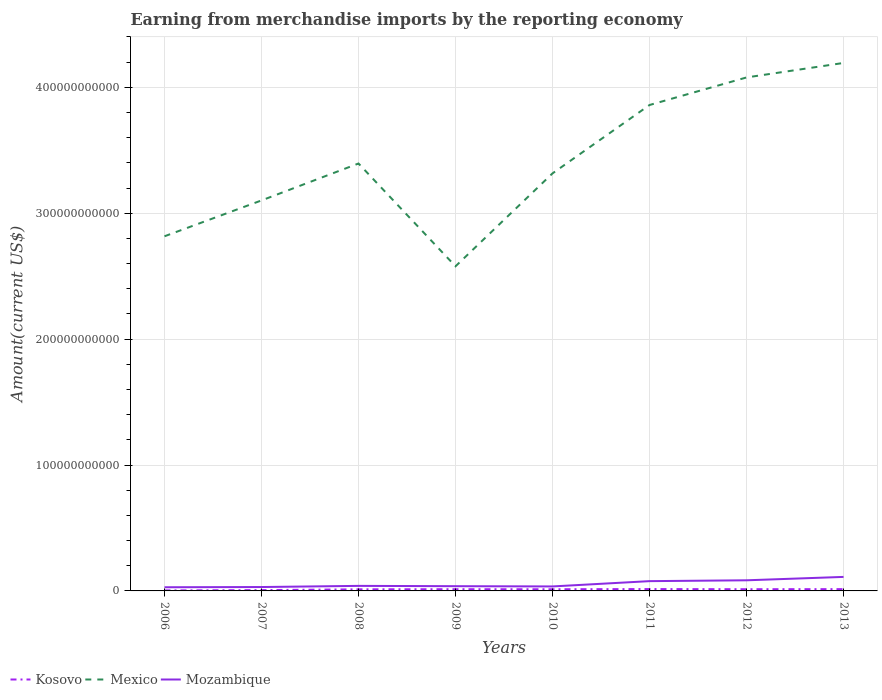How many different coloured lines are there?
Your answer should be very brief. 3. Does the line corresponding to Mozambique intersect with the line corresponding to Mexico?
Your response must be concise. No. Across all years, what is the maximum amount earned from merchandise imports in Mexico?
Ensure brevity in your answer.  2.58e+11. In which year was the amount earned from merchandise imports in Kosovo maximum?
Your answer should be compact. 2006. What is the total amount earned from merchandise imports in Kosovo in the graph?
Offer a terse response. -7.19e+08. What is the difference between the highest and the second highest amount earned from merchandise imports in Mozambique?
Your response must be concise. 8.22e+09. Is the amount earned from merchandise imports in Kosovo strictly greater than the amount earned from merchandise imports in Mozambique over the years?
Provide a succinct answer. Yes. What is the difference between two consecutive major ticks on the Y-axis?
Keep it short and to the point. 1.00e+11. Does the graph contain any zero values?
Offer a terse response. No. Where does the legend appear in the graph?
Offer a very short reply. Bottom left. How many legend labels are there?
Offer a terse response. 3. How are the legend labels stacked?
Keep it short and to the point. Horizontal. What is the title of the graph?
Provide a short and direct response. Earning from merchandise imports by the reporting economy. Does "Bermuda" appear as one of the legend labels in the graph?
Your answer should be very brief. No. What is the label or title of the Y-axis?
Your response must be concise. Amount(current US$). What is the Amount(current US$) of Kosovo in 2006?
Your answer should be very brief. 3.87e+08. What is the Amount(current US$) of Mexico in 2006?
Your response must be concise. 2.82e+11. What is the Amount(current US$) in Mozambique in 2006?
Your answer should be compact. 2.91e+09. What is the Amount(current US$) of Kosovo in 2007?
Your answer should be compact. 6.45e+08. What is the Amount(current US$) in Mexico in 2007?
Provide a short and direct response. 3.10e+11. What is the Amount(current US$) in Mozambique in 2007?
Your response must be concise. 3.09e+09. What is the Amount(current US$) in Kosovo in 2008?
Offer a terse response. 1.27e+09. What is the Amount(current US$) in Mexico in 2008?
Ensure brevity in your answer.  3.39e+11. What is the Amount(current US$) in Mozambique in 2008?
Provide a succinct answer. 4.01e+09. What is the Amount(current US$) in Kosovo in 2009?
Your answer should be compact. 1.36e+09. What is the Amount(current US$) in Mexico in 2009?
Keep it short and to the point. 2.58e+11. What is the Amount(current US$) of Mozambique in 2009?
Provide a short and direct response. 3.76e+09. What is the Amount(current US$) in Kosovo in 2010?
Keep it short and to the point. 1.32e+09. What is the Amount(current US$) in Mexico in 2010?
Keep it short and to the point. 3.32e+11. What is the Amount(current US$) in Mozambique in 2010?
Your answer should be compact. 3.56e+09. What is the Amount(current US$) in Kosovo in 2011?
Provide a succinct answer. 1.47e+09. What is the Amount(current US$) of Mexico in 2011?
Keep it short and to the point. 3.86e+11. What is the Amount(current US$) of Mozambique in 2011?
Give a very brief answer. 7.76e+09. What is the Amount(current US$) in Kosovo in 2012?
Make the answer very short. 1.35e+09. What is the Amount(current US$) in Mexico in 2012?
Offer a terse response. 4.08e+11. What is the Amount(current US$) in Mozambique in 2012?
Provide a short and direct response. 8.43e+09. What is the Amount(current US$) in Kosovo in 2013?
Keep it short and to the point. 1.42e+09. What is the Amount(current US$) in Mexico in 2013?
Your answer should be compact. 4.19e+11. What is the Amount(current US$) of Mozambique in 2013?
Keep it short and to the point. 1.11e+1. Across all years, what is the maximum Amount(current US$) in Kosovo?
Give a very brief answer. 1.47e+09. Across all years, what is the maximum Amount(current US$) of Mexico?
Make the answer very short. 4.19e+11. Across all years, what is the maximum Amount(current US$) in Mozambique?
Give a very brief answer. 1.11e+1. Across all years, what is the minimum Amount(current US$) of Kosovo?
Provide a short and direct response. 3.87e+08. Across all years, what is the minimum Amount(current US$) in Mexico?
Make the answer very short. 2.58e+11. Across all years, what is the minimum Amount(current US$) in Mozambique?
Make the answer very short. 2.91e+09. What is the total Amount(current US$) of Kosovo in the graph?
Keep it short and to the point. 9.23e+09. What is the total Amount(current US$) in Mexico in the graph?
Keep it short and to the point. 2.73e+12. What is the total Amount(current US$) of Mozambique in the graph?
Offer a terse response. 4.47e+1. What is the difference between the Amount(current US$) of Kosovo in 2006 and that in 2007?
Your answer should be compact. -2.58e+08. What is the difference between the Amount(current US$) of Mexico in 2006 and that in 2007?
Offer a terse response. -2.85e+1. What is the difference between the Amount(current US$) in Mozambique in 2006 and that in 2007?
Your response must be concise. -1.79e+08. What is the difference between the Amount(current US$) of Kosovo in 2006 and that in 2008?
Offer a terse response. -8.84e+08. What is the difference between the Amount(current US$) of Mexico in 2006 and that in 2008?
Your answer should be very brief. -5.78e+1. What is the difference between the Amount(current US$) in Mozambique in 2006 and that in 2008?
Ensure brevity in your answer.  -1.09e+09. What is the difference between the Amount(current US$) of Kosovo in 2006 and that in 2009?
Provide a succinct answer. -9.77e+08. What is the difference between the Amount(current US$) in Mexico in 2006 and that in 2009?
Provide a short and direct response. 2.38e+1. What is the difference between the Amount(current US$) of Mozambique in 2006 and that in 2009?
Make the answer very short. -8.50e+08. What is the difference between the Amount(current US$) in Kosovo in 2006 and that in 2010?
Provide a succinct answer. -9.32e+08. What is the difference between the Amount(current US$) of Mexico in 2006 and that in 2010?
Give a very brief answer. -5.00e+1. What is the difference between the Amount(current US$) of Mozambique in 2006 and that in 2010?
Give a very brief answer. -6.51e+08. What is the difference between the Amount(current US$) of Kosovo in 2006 and that in 2011?
Ensure brevity in your answer.  -1.09e+09. What is the difference between the Amount(current US$) of Mexico in 2006 and that in 2011?
Provide a succinct answer. -1.04e+11. What is the difference between the Amount(current US$) of Mozambique in 2006 and that in 2011?
Ensure brevity in your answer.  -4.85e+09. What is the difference between the Amount(current US$) of Kosovo in 2006 and that in 2012?
Provide a short and direct response. -9.65e+08. What is the difference between the Amount(current US$) of Mexico in 2006 and that in 2012?
Provide a short and direct response. -1.26e+11. What is the difference between the Amount(current US$) in Mozambique in 2006 and that in 2012?
Your answer should be very brief. -5.52e+09. What is the difference between the Amount(current US$) of Kosovo in 2006 and that in 2013?
Your answer should be compact. -1.03e+09. What is the difference between the Amount(current US$) in Mexico in 2006 and that in 2013?
Provide a short and direct response. -1.38e+11. What is the difference between the Amount(current US$) in Mozambique in 2006 and that in 2013?
Your answer should be very brief. -8.22e+09. What is the difference between the Amount(current US$) of Kosovo in 2007 and that in 2008?
Keep it short and to the point. -6.26e+08. What is the difference between the Amount(current US$) of Mexico in 2007 and that in 2008?
Ensure brevity in your answer.  -2.93e+1. What is the difference between the Amount(current US$) of Mozambique in 2007 and that in 2008?
Offer a very short reply. -9.16e+08. What is the difference between the Amount(current US$) in Kosovo in 2007 and that in 2009?
Offer a terse response. -7.19e+08. What is the difference between the Amount(current US$) of Mexico in 2007 and that in 2009?
Your answer should be compact. 5.23e+1. What is the difference between the Amount(current US$) of Mozambique in 2007 and that in 2009?
Offer a terse response. -6.72e+08. What is the difference between the Amount(current US$) in Kosovo in 2007 and that in 2010?
Provide a short and direct response. -6.74e+08. What is the difference between the Amount(current US$) of Mexico in 2007 and that in 2010?
Make the answer very short. -2.15e+1. What is the difference between the Amount(current US$) of Mozambique in 2007 and that in 2010?
Keep it short and to the point. -4.72e+08. What is the difference between the Amount(current US$) in Kosovo in 2007 and that in 2011?
Give a very brief answer. -8.27e+08. What is the difference between the Amount(current US$) in Mexico in 2007 and that in 2011?
Offer a terse response. -7.58e+1. What is the difference between the Amount(current US$) of Mozambique in 2007 and that in 2011?
Give a very brief answer. -4.67e+09. What is the difference between the Amount(current US$) of Kosovo in 2007 and that in 2012?
Keep it short and to the point. -7.07e+08. What is the difference between the Amount(current US$) of Mexico in 2007 and that in 2012?
Give a very brief answer. -9.77e+1. What is the difference between the Amount(current US$) in Mozambique in 2007 and that in 2012?
Your answer should be very brief. -5.34e+09. What is the difference between the Amount(current US$) in Kosovo in 2007 and that in 2013?
Provide a short and direct response. -7.72e+08. What is the difference between the Amount(current US$) in Mexico in 2007 and that in 2013?
Give a very brief answer. -1.09e+11. What is the difference between the Amount(current US$) in Mozambique in 2007 and that in 2013?
Provide a succinct answer. -8.04e+09. What is the difference between the Amount(current US$) of Kosovo in 2008 and that in 2009?
Ensure brevity in your answer.  -9.32e+07. What is the difference between the Amount(current US$) of Mexico in 2008 and that in 2009?
Your response must be concise. 8.16e+1. What is the difference between the Amount(current US$) in Mozambique in 2008 and that in 2009?
Provide a succinct answer. 2.44e+08. What is the difference between the Amount(current US$) in Kosovo in 2008 and that in 2010?
Provide a succinct answer. -4.82e+07. What is the difference between the Amount(current US$) of Mexico in 2008 and that in 2010?
Ensure brevity in your answer.  7.83e+09. What is the difference between the Amount(current US$) in Mozambique in 2008 and that in 2010?
Ensure brevity in your answer.  4.44e+08. What is the difference between the Amount(current US$) in Kosovo in 2008 and that in 2011?
Your response must be concise. -2.01e+08. What is the difference between the Amount(current US$) of Mexico in 2008 and that in 2011?
Provide a short and direct response. -4.65e+1. What is the difference between the Amount(current US$) of Mozambique in 2008 and that in 2011?
Your answer should be compact. -3.76e+09. What is the difference between the Amount(current US$) of Kosovo in 2008 and that in 2012?
Give a very brief answer. -8.09e+07. What is the difference between the Amount(current US$) of Mexico in 2008 and that in 2012?
Make the answer very short. -6.84e+1. What is the difference between the Amount(current US$) of Mozambique in 2008 and that in 2012?
Your response must be concise. -4.43e+09. What is the difference between the Amount(current US$) in Kosovo in 2008 and that in 2013?
Give a very brief answer. -1.46e+08. What is the difference between the Amount(current US$) of Mexico in 2008 and that in 2013?
Offer a very short reply. -7.99e+1. What is the difference between the Amount(current US$) in Mozambique in 2008 and that in 2013?
Provide a short and direct response. -7.12e+09. What is the difference between the Amount(current US$) of Kosovo in 2009 and that in 2010?
Provide a short and direct response. 4.51e+07. What is the difference between the Amount(current US$) in Mexico in 2009 and that in 2010?
Ensure brevity in your answer.  -7.38e+1. What is the difference between the Amount(current US$) of Mozambique in 2009 and that in 2010?
Make the answer very short. 2.00e+08. What is the difference between the Amount(current US$) of Kosovo in 2009 and that in 2011?
Your answer should be very brief. -1.08e+08. What is the difference between the Amount(current US$) in Mexico in 2009 and that in 2011?
Give a very brief answer. -1.28e+11. What is the difference between the Amount(current US$) in Mozambique in 2009 and that in 2011?
Your answer should be compact. -4.00e+09. What is the difference between the Amount(current US$) of Kosovo in 2009 and that in 2012?
Ensure brevity in your answer.  1.23e+07. What is the difference between the Amount(current US$) of Mexico in 2009 and that in 2012?
Your answer should be compact. -1.50e+11. What is the difference between the Amount(current US$) of Mozambique in 2009 and that in 2012?
Keep it short and to the point. -4.67e+09. What is the difference between the Amount(current US$) in Kosovo in 2009 and that in 2013?
Provide a short and direct response. -5.29e+07. What is the difference between the Amount(current US$) in Mexico in 2009 and that in 2013?
Offer a terse response. -1.62e+11. What is the difference between the Amount(current US$) of Mozambique in 2009 and that in 2013?
Make the answer very short. -7.37e+09. What is the difference between the Amount(current US$) of Kosovo in 2010 and that in 2011?
Give a very brief answer. -1.53e+08. What is the difference between the Amount(current US$) of Mexico in 2010 and that in 2011?
Give a very brief answer. -5.43e+1. What is the difference between the Amount(current US$) in Mozambique in 2010 and that in 2011?
Provide a short and direct response. -4.20e+09. What is the difference between the Amount(current US$) of Kosovo in 2010 and that in 2012?
Offer a terse response. -3.27e+07. What is the difference between the Amount(current US$) in Mexico in 2010 and that in 2012?
Your answer should be very brief. -7.62e+1. What is the difference between the Amount(current US$) of Mozambique in 2010 and that in 2012?
Provide a succinct answer. -4.87e+09. What is the difference between the Amount(current US$) in Kosovo in 2010 and that in 2013?
Make the answer very short. -9.80e+07. What is the difference between the Amount(current US$) of Mexico in 2010 and that in 2013?
Offer a terse response. -8.77e+1. What is the difference between the Amount(current US$) in Mozambique in 2010 and that in 2013?
Make the answer very short. -7.57e+09. What is the difference between the Amount(current US$) of Kosovo in 2011 and that in 2012?
Your answer should be compact. 1.20e+08. What is the difference between the Amount(current US$) in Mexico in 2011 and that in 2012?
Make the answer very short. -2.19e+1. What is the difference between the Amount(current US$) of Mozambique in 2011 and that in 2012?
Your answer should be very brief. -6.71e+08. What is the difference between the Amount(current US$) in Kosovo in 2011 and that in 2013?
Keep it short and to the point. 5.49e+07. What is the difference between the Amount(current US$) in Mexico in 2011 and that in 2013?
Ensure brevity in your answer.  -3.34e+1. What is the difference between the Amount(current US$) in Mozambique in 2011 and that in 2013?
Offer a terse response. -3.37e+09. What is the difference between the Amount(current US$) of Kosovo in 2012 and that in 2013?
Your answer should be compact. -6.52e+07. What is the difference between the Amount(current US$) of Mexico in 2012 and that in 2013?
Offer a very short reply. -1.15e+1. What is the difference between the Amount(current US$) of Mozambique in 2012 and that in 2013?
Ensure brevity in your answer.  -2.70e+09. What is the difference between the Amount(current US$) of Kosovo in 2006 and the Amount(current US$) of Mexico in 2007?
Your answer should be very brief. -3.10e+11. What is the difference between the Amount(current US$) in Kosovo in 2006 and the Amount(current US$) in Mozambique in 2007?
Your answer should be compact. -2.71e+09. What is the difference between the Amount(current US$) of Mexico in 2006 and the Amount(current US$) of Mozambique in 2007?
Keep it short and to the point. 2.79e+11. What is the difference between the Amount(current US$) of Kosovo in 2006 and the Amount(current US$) of Mexico in 2008?
Make the answer very short. -3.39e+11. What is the difference between the Amount(current US$) of Kosovo in 2006 and the Amount(current US$) of Mozambique in 2008?
Provide a short and direct response. -3.62e+09. What is the difference between the Amount(current US$) in Mexico in 2006 and the Amount(current US$) in Mozambique in 2008?
Provide a succinct answer. 2.78e+11. What is the difference between the Amount(current US$) in Kosovo in 2006 and the Amount(current US$) in Mexico in 2009?
Make the answer very short. -2.57e+11. What is the difference between the Amount(current US$) of Kosovo in 2006 and the Amount(current US$) of Mozambique in 2009?
Your answer should be very brief. -3.38e+09. What is the difference between the Amount(current US$) of Mexico in 2006 and the Amount(current US$) of Mozambique in 2009?
Give a very brief answer. 2.78e+11. What is the difference between the Amount(current US$) in Kosovo in 2006 and the Amount(current US$) in Mexico in 2010?
Your answer should be compact. -3.31e+11. What is the difference between the Amount(current US$) in Kosovo in 2006 and the Amount(current US$) in Mozambique in 2010?
Your response must be concise. -3.18e+09. What is the difference between the Amount(current US$) in Mexico in 2006 and the Amount(current US$) in Mozambique in 2010?
Provide a short and direct response. 2.78e+11. What is the difference between the Amount(current US$) in Kosovo in 2006 and the Amount(current US$) in Mexico in 2011?
Make the answer very short. -3.86e+11. What is the difference between the Amount(current US$) in Kosovo in 2006 and the Amount(current US$) in Mozambique in 2011?
Ensure brevity in your answer.  -7.38e+09. What is the difference between the Amount(current US$) in Mexico in 2006 and the Amount(current US$) in Mozambique in 2011?
Give a very brief answer. 2.74e+11. What is the difference between the Amount(current US$) in Kosovo in 2006 and the Amount(current US$) in Mexico in 2012?
Offer a very short reply. -4.07e+11. What is the difference between the Amount(current US$) of Kosovo in 2006 and the Amount(current US$) of Mozambique in 2012?
Offer a very short reply. -8.05e+09. What is the difference between the Amount(current US$) of Mexico in 2006 and the Amount(current US$) of Mozambique in 2012?
Offer a very short reply. 2.73e+11. What is the difference between the Amount(current US$) in Kosovo in 2006 and the Amount(current US$) in Mexico in 2013?
Your answer should be very brief. -4.19e+11. What is the difference between the Amount(current US$) in Kosovo in 2006 and the Amount(current US$) in Mozambique in 2013?
Your response must be concise. -1.07e+1. What is the difference between the Amount(current US$) in Mexico in 2006 and the Amount(current US$) in Mozambique in 2013?
Make the answer very short. 2.71e+11. What is the difference between the Amount(current US$) of Kosovo in 2007 and the Amount(current US$) of Mexico in 2008?
Your answer should be very brief. -3.39e+11. What is the difference between the Amount(current US$) of Kosovo in 2007 and the Amount(current US$) of Mozambique in 2008?
Provide a succinct answer. -3.36e+09. What is the difference between the Amount(current US$) in Mexico in 2007 and the Amount(current US$) in Mozambique in 2008?
Provide a succinct answer. 3.06e+11. What is the difference between the Amount(current US$) in Kosovo in 2007 and the Amount(current US$) in Mexico in 2009?
Provide a succinct answer. -2.57e+11. What is the difference between the Amount(current US$) of Kosovo in 2007 and the Amount(current US$) of Mozambique in 2009?
Provide a short and direct response. -3.12e+09. What is the difference between the Amount(current US$) of Mexico in 2007 and the Amount(current US$) of Mozambique in 2009?
Keep it short and to the point. 3.06e+11. What is the difference between the Amount(current US$) in Kosovo in 2007 and the Amount(current US$) in Mexico in 2010?
Provide a succinct answer. -3.31e+11. What is the difference between the Amount(current US$) in Kosovo in 2007 and the Amount(current US$) in Mozambique in 2010?
Your answer should be very brief. -2.92e+09. What is the difference between the Amount(current US$) of Mexico in 2007 and the Amount(current US$) of Mozambique in 2010?
Your answer should be very brief. 3.07e+11. What is the difference between the Amount(current US$) in Kosovo in 2007 and the Amount(current US$) in Mexico in 2011?
Ensure brevity in your answer.  -3.85e+11. What is the difference between the Amount(current US$) of Kosovo in 2007 and the Amount(current US$) of Mozambique in 2011?
Offer a terse response. -7.12e+09. What is the difference between the Amount(current US$) of Mexico in 2007 and the Amount(current US$) of Mozambique in 2011?
Your answer should be compact. 3.02e+11. What is the difference between the Amount(current US$) in Kosovo in 2007 and the Amount(current US$) in Mexico in 2012?
Keep it short and to the point. -4.07e+11. What is the difference between the Amount(current US$) of Kosovo in 2007 and the Amount(current US$) of Mozambique in 2012?
Your response must be concise. -7.79e+09. What is the difference between the Amount(current US$) in Mexico in 2007 and the Amount(current US$) in Mozambique in 2012?
Your response must be concise. 3.02e+11. What is the difference between the Amount(current US$) of Kosovo in 2007 and the Amount(current US$) of Mexico in 2013?
Offer a very short reply. -4.19e+11. What is the difference between the Amount(current US$) in Kosovo in 2007 and the Amount(current US$) in Mozambique in 2013?
Ensure brevity in your answer.  -1.05e+1. What is the difference between the Amount(current US$) in Mexico in 2007 and the Amount(current US$) in Mozambique in 2013?
Provide a short and direct response. 2.99e+11. What is the difference between the Amount(current US$) of Kosovo in 2008 and the Amount(current US$) of Mexico in 2009?
Give a very brief answer. -2.57e+11. What is the difference between the Amount(current US$) in Kosovo in 2008 and the Amount(current US$) in Mozambique in 2009?
Make the answer very short. -2.49e+09. What is the difference between the Amount(current US$) in Mexico in 2008 and the Amount(current US$) in Mozambique in 2009?
Your answer should be compact. 3.36e+11. What is the difference between the Amount(current US$) of Kosovo in 2008 and the Amount(current US$) of Mexico in 2010?
Offer a terse response. -3.30e+11. What is the difference between the Amount(current US$) of Kosovo in 2008 and the Amount(current US$) of Mozambique in 2010?
Make the answer very short. -2.29e+09. What is the difference between the Amount(current US$) of Mexico in 2008 and the Amount(current US$) of Mozambique in 2010?
Provide a succinct answer. 3.36e+11. What is the difference between the Amount(current US$) in Kosovo in 2008 and the Amount(current US$) in Mexico in 2011?
Offer a very short reply. -3.85e+11. What is the difference between the Amount(current US$) in Kosovo in 2008 and the Amount(current US$) in Mozambique in 2011?
Keep it short and to the point. -6.49e+09. What is the difference between the Amount(current US$) of Mexico in 2008 and the Amount(current US$) of Mozambique in 2011?
Give a very brief answer. 3.32e+11. What is the difference between the Amount(current US$) of Kosovo in 2008 and the Amount(current US$) of Mexico in 2012?
Make the answer very short. -4.07e+11. What is the difference between the Amount(current US$) in Kosovo in 2008 and the Amount(current US$) in Mozambique in 2012?
Keep it short and to the point. -7.16e+09. What is the difference between the Amount(current US$) of Mexico in 2008 and the Amount(current US$) of Mozambique in 2012?
Keep it short and to the point. 3.31e+11. What is the difference between the Amount(current US$) in Kosovo in 2008 and the Amount(current US$) in Mexico in 2013?
Your response must be concise. -4.18e+11. What is the difference between the Amount(current US$) in Kosovo in 2008 and the Amount(current US$) in Mozambique in 2013?
Make the answer very short. -9.86e+09. What is the difference between the Amount(current US$) of Mexico in 2008 and the Amount(current US$) of Mozambique in 2013?
Ensure brevity in your answer.  3.28e+11. What is the difference between the Amount(current US$) in Kosovo in 2009 and the Amount(current US$) in Mexico in 2010?
Your response must be concise. -3.30e+11. What is the difference between the Amount(current US$) in Kosovo in 2009 and the Amount(current US$) in Mozambique in 2010?
Keep it short and to the point. -2.20e+09. What is the difference between the Amount(current US$) of Mexico in 2009 and the Amount(current US$) of Mozambique in 2010?
Your answer should be compact. 2.54e+11. What is the difference between the Amount(current US$) in Kosovo in 2009 and the Amount(current US$) in Mexico in 2011?
Your answer should be very brief. -3.85e+11. What is the difference between the Amount(current US$) of Kosovo in 2009 and the Amount(current US$) of Mozambique in 2011?
Your answer should be compact. -6.40e+09. What is the difference between the Amount(current US$) in Mexico in 2009 and the Amount(current US$) in Mozambique in 2011?
Keep it short and to the point. 2.50e+11. What is the difference between the Amount(current US$) in Kosovo in 2009 and the Amount(current US$) in Mexico in 2012?
Your answer should be very brief. -4.06e+11. What is the difference between the Amount(current US$) of Kosovo in 2009 and the Amount(current US$) of Mozambique in 2012?
Ensure brevity in your answer.  -7.07e+09. What is the difference between the Amount(current US$) in Mexico in 2009 and the Amount(current US$) in Mozambique in 2012?
Offer a terse response. 2.49e+11. What is the difference between the Amount(current US$) of Kosovo in 2009 and the Amount(current US$) of Mexico in 2013?
Offer a very short reply. -4.18e+11. What is the difference between the Amount(current US$) of Kosovo in 2009 and the Amount(current US$) of Mozambique in 2013?
Your answer should be very brief. -9.77e+09. What is the difference between the Amount(current US$) of Mexico in 2009 and the Amount(current US$) of Mozambique in 2013?
Offer a terse response. 2.47e+11. What is the difference between the Amount(current US$) of Kosovo in 2010 and the Amount(current US$) of Mexico in 2011?
Provide a succinct answer. -3.85e+11. What is the difference between the Amount(current US$) of Kosovo in 2010 and the Amount(current US$) of Mozambique in 2011?
Offer a terse response. -6.44e+09. What is the difference between the Amount(current US$) in Mexico in 2010 and the Amount(current US$) in Mozambique in 2011?
Your response must be concise. 3.24e+11. What is the difference between the Amount(current US$) in Kosovo in 2010 and the Amount(current US$) in Mexico in 2012?
Your response must be concise. -4.07e+11. What is the difference between the Amount(current US$) in Kosovo in 2010 and the Amount(current US$) in Mozambique in 2012?
Offer a terse response. -7.12e+09. What is the difference between the Amount(current US$) in Mexico in 2010 and the Amount(current US$) in Mozambique in 2012?
Provide a short and direct response. 3.23e+11. What is the difference between the Amount(current US$) of Kosovo in 2010 and the Amount(current US$) of Mexico in 2013?
Keep it short and to the point. -4.18e+11. What is the difference between the Amount(current US$) of Kosovo in 2010 and the Amount(current US$) of Mozambique in 2013?
Your response must be concise. -9.81e+09. What is the difference between the Amount(current US$) of Mexico in 2010 and the Amount(current US$) of Mozambique in 2013?
Offer a very short reply. 3.20e+11. What is the difference between the Amount(current US$) in Kosovo in 2011 and the Amount(current US$) in Mexico in 2012?
Your answer should be compact. -4.06e+11. What is the difference between the Amount(current US$) in Kosovo in 2011 and the Amount(current US$) in Mozambique in 2012?
Give a very brief answer. -6.96e+09. What is the difference between the Amount(current US$) of Mexico in 2011 and the Amount(current US$) of Mozambique in 2012?
Ensure brevity in your answer.  3.77e+11. What is the difference between the Amount(current US$) in Kosovo in 2011 and the Amount(current US$) in Mexico in 2013?
Ensure brevity in your answer.  -4.18e+11. What is the difference between the Amount(current US$) of Kosovo in 2011 and the Amount(current US$) of Mozambique in 2013?
Your answer should be very brief. -9.66e+09. What is the difference between the Amount(current US$) in Mexico in 2011 and the Amount(current US$) in Mozambique in 2013?
Keep it short and to the point. 3.75e+11. What is the difference between the Amount(current US$) in Kosovo in 2012 and the Amount(current US$) in Mexico in 2013?
Your answer should be very brief. -4.18e+11. What is the difference between the Amount(current US$) in Kosovo in 2012 and the Amount(current US$) in Mozambique in 2013?
Your answer should be compact. -9.78e+09. What is the difference between the Amount(current US$) of Mexico in 2012 and the Amount(current US$) of Mozambique in 2013?
Give a very brief answer. 3.97e+11. What is the average Amount(current US$) of Kosovo per year?
Your answer should be compact. 1.15e+09. What is the average Amount(current US$) in Mexico per year?
Keep it short and to the point. 3.42e+11. What is the average Amount(current US$) of Mozambique per year?
Offer a very short reply. 5.58e+09. In the year 2006, what is the difference between the Amount(current US$) in Kosovo and Amount(current US$) in Mexico?
Keep it short and to the point. -2.81e+11. In the year 2006, what is the difference between the Amount(current US$) in Kosovo and Amount(current US$) in Mozambique?
Make the answer very short. -2.53e+09. In the year 2006, what is the difference between the Amount(current US$) of Mexico and Amount(current US$) of Mozambique?
Give a very brief answer. 2.79e+11. In the year 2007, what is the difference between the Amount(current US$) of Kosovo and Amount(current US$) of Mexico?
Provide a short and direct response. -3.09e+11. In the year 2007, what is the difference between the Amount(current US$) of Kosovo and Amount(current US$) of Mozambique?
Ensure brevity in your answer.  -2.45e+09. In the year 2007, what is the difference between the Amount(current US$) of Mexico and Amount(current US$) of Mozambique?
Ensure brevity in your answer.  3.07e+11. In the year 2008, what is the difference between the Amount(current US$) of Kosovo and Amount(current US$) of Mexico?
Make the answer very short. -3.38e+11. In the year 2008, what is the difference between the Amount(current US$) of Kosovo and Amount(current US$) of Mozambique?
Your answer should be very brief. -2.74e+09. In the year 2008, what is the difference between the Amount(current US$) of Mexico and Amount(current US$) of Mozambique?
Keep it short and to the point. 3.35e+11. In the year 2009, what is the difference between the Amount(current US$) of Kosovo and Amount(current US$) of Mexico?
Your answer should be compact. -2.56e+11. In the year 2009, what is the difference between the Amount(current US$) of Kosovo and Amount(current US$) of Mozambique?
Make the answer very short. -2.40e+09. In the year 2009, what is the difference between the Amount(current US$) in Mexico and Amount(current US$) in Mozambique?
Ensure brevity in your answer.  2.54e+11. In the year 2010, what is the difference between the Amount(current US$) in Kosovo and Amount(current US$) in Mexico?
Offer a very short reply. -3.30e+11. In the year 2010, what is the difference between the Amount(current US$) of Kosovo and Amount(current US$) of Mozambique?
Provide a short and direct response. -2.24e+09. In the year 2010, what is the difference between the Amount(current US$) in Mexico and Amount(current US$) in Mozambique?
Ensure brevity in your answer.  3.28e+11. In the year 2011, what is the difference between the Amount(current US$) in Kosovo and Amount(current US$) in Mexico?
Your response must be concise. -3.84e+11. In the year 2011, what is the difference between the Amount(current US$) in Kosovo and Amount(current US$) in Mozambique?
Offer a very short reply. -6.29e+09. In the year 2011, what is the difference between the Amount(current US$) in Mexico and Amount(current US$) in Mozambique?
Offer a very short reply. 3.78e+11. In the year 2012, what is the difference between the Amount(current US$) in Kosovo and Amount(current US$) in Mexico?
Your response must be concise. -4.06e+11. In the year 2012, what is the difference between the Amount(current US$) of Kosovo and Amount(current US$) of Mozambique?
Your response must be concise. -7.08e+09. In the year 2012, what is the difference between the Amount(current US$) in Mexico and Amount(current US$) in Mozambique?
Your response must be concise. 3.99e+11. In the year 2013, what is the difference between the Amount(current US$) in Kosovo and Amount(current US$) in Mexico?
Offer a very short reply. -4.18e+11. In the year 2013, what is the difference between the Amount(current US$) of Kosovo and Amount(current US$) of Mozambique?
Offer a terse response. -9.72e+09. In the year 2013, what is the difference between the Amount(current US$) in Mexico and Amount(current US$) in Mozambique?
Give a very brief answer. 4.08e+11. What is the ratio of the Amount(current US$) in Kosovo in 2006 to that in 2007?
Make the answer very short. 0.6. What is the ratio of the Amount(current US$) in Mexico in 2006 to that in 2007?
Offer a very short reply. 0.91. What is the ratio of the Amount(current US$) in Mozambique in 2006 to that in 2007?
Your response must be concise. 0.94. What is the ratio of the Amount(current US$) in Kosovo in 2006 to that in 2008?
Offer a terse response. 0.3. What is the ratio of the Amount(current US$) in Mexico in 2006 to that in 2008?
Give a very brief answer. 0.83. What is the ratio of the Amount(current US$) in Mozambique in 2006 to that in 2008?
Your answer should be compact. 0.73. What is the ratio of the Amount(current US$) in Kosovo in 2006 to that in 2009?
Your answer should be compact. 0.28. What is the ratio of the Amount(current US$) of Mexico in 2006 to that in 2009?
Your response must be concise. 1.09. What is the ratio of the Amount(current US$) of Mozambique in 2006 to that in 2009?
Your response must be concise. 0.77. What is the ratio of the Amount(current US$) of Kosovo in 2006 to that in 2010?
Your response must be concise. 0.29. What is the ratio of the Amount(current US$) in Mexico in 2006 to that in 2010?
Offer a very short reply. 0.85. What is the ratio of the Amount(current US$) of Mozambique in 2006 to that in 2010?
Your response must be concise. 0.82. What is the ratio of the Amount(current US$) of Kosovo in 2006 to that in 2011?
Your answer should be compact. 0.26. What is the ratio of the Amount(current US$) of Mexico in 2006 to that in 2011?
Give a very brief answer. 0.73. What is the ratio of the Amount(current US$) of Mozambique in 2006 to that in 2011?
Your answer should be compact. 0.38. What is the ratio of the Amount(current US$) in Kosovo in 2006 to that in 2012?
Your response must be concise. 0.29. What is the ratio of the Amount(current US$) of Mexico in 2006 to that in 2012?
Give a very brief answer. 0.69. What is the ratio of the Amount(current US$) of Mozambique in 2006 to that in 2012?
Provide a succinct answer. 0.35. What is the ratio of the Amount(current US$) of Kosovo in 2006 to that in 2013?
Make the answer very short. 0.27. What is the ratio of the Amount(current US$) of Mexico in 2006 to that in 2013?
Offer a very short reply. 0.67. What is the ratio of the Amount(current US$) in Mozambique in 2006 to that in 2013?
Offer a terse response. 0.26. What is the ratio of the Amount(current US$) of Kosovo in 2007 to that in 2008?
Provide a succinct answer. 0.51. What is the ratio of the Amount(current US$) in Mexico in 2007 to that in 2008?
Keep it short and to the point. 0.91. What is the ratio of the Amount(current US$) in Mozambique in 2007 to that in 2008?
Make the answer very short. 0.77. What is the ratio of the Amount(current US$) in Kosovo in 2007 to that in 2009?
Your response must be concise. 0.47. What is the ratio of the Amount(current US$) in Mexico in 2007 to that in 2009?
Keep it short and to the point. 1.2. What is the ratio of the Amount(current US$) of Mozambique in 2007 to that in 2009?
Make the answer very short. 0.82. What is the ratio of the Amount(current US$) of Kosovo in 2007 to that in 2010?
Your answer should be very brief. 0.49. What is the ratio of the Amount(current US$) of Mexico in 2007 to that in 2010?
Your response must be concise. 0.94. What is the ratio of the Amount(current US$) in Mozambique in 2007 to that in 2010?
Make the answer very short. 0.87. What is the ratio of the Amount(current US$) of Kosovo in 2007 to that in 2011?
Your response must be concise. 0.44. What is the ratio of the Amount(current US$) of Mexico in 2007 to that in 2011?
Your response must be concise. 0.8. What is the ratio of the Amount(current US$) of Mozambique in 2007 to that in 2011?
Provide a succinct answer. 0.4. What is the ratio of the Amount(current US$) of Kosovo in 2007 to that in 2012?
Provide a succinct answer. 0.48. What is the ratio of the Amount(current US$) of Mexico in 2007 to that in 2012?
Offer a very short reply. 0.76. What is the ratio of the Amount(current US$) in Mozambique in 2007 to that in 2012?
Ensure brevity in your answer.  0.37. What is the ratio of the Amount(current US$) in Kosovo in 2007 to that in 2013?
Make the answer very short. 0.46. What is the ratio of the Amount(current US$) of Mexico in 2007 to that in 2013?
Provide a succinct answer. 0.74. What is the ratio of the Amount(current US$) of Mozambique in 2007 to that in 2013?
Provide a succinct answer. 0.28. What is the ratio of the Amount(current US$) of Kosovo in 2008 to that in 2009?
Your response must be concise. 0.93. What is the ratio of the Amount(current US$) of Mexico in 2008 to that in 2009?
Ensure brevity in your answer.  1.32. What is the ratio of the Amount(current US$) of Mozambique in 2008 to that in 2009?
Provide a short and direct response. 1.06. What is the ratio of the Amount(current US$) of Kosovo in 2008 to that in 2010?
Keep it short and to the point. 0.96. What is the ratio of the Amount(current US$) in Mexico in 2008 to that in 2010?
Keep it short and to the point. 1.02. What is the ratio of the Amount(current US$) of Mozambique in 2008 to that in 2010?
Your response must be concise. 1.12. What is the ratio of the Amount(current US$) in Kosovo in 2008 to that in 2011?
Provide a succinct answer. 0.86. What is the ratio of the Amount(current US$) of Mexico in 2008 to that in 2011?
Provide a short and direct response. 0.88. What is the ratio of the Amount(current US$) in Mozambique in 2008 to that in 2011?
Keep it short and to the point. 0.52. What is the ratio of the Amount(current US$) of Kosovo in 2008 to that in 2012?
Provide a succinct answer. 0.94. What is the ratio of the Amount(current US$) of Mexico in 2008 to that in 2012?
Offer a very short reply. 0.83. What is the ratio of the Amount(current US$) of Mozambique in 2008 to that in 2012?
Provide a succinct answer. 0.48. What is the ratio of the Amount(current US$) in Kosovo in 2008 to that in 2013?
Keep it short and to the point. 0.9. What is the ratio of the Amount(current US$) of Mexico in 2008 to that in 2013?
Your response must be concise. 0.81. What is the ratio of the Amount(current US$) of Mozambique in 2008 to that in 2013?
Provide a short and direct response. 0.36. What is the ratio of the Amount(current US$) in Kosovo in 2009 to that in 2010?
Give a very brief answer. 1.03. What is the ratio of the Amount(current US$) in Mexico in 2009 to that in 2010?
Offer a very short reply. 0.78. What is the ratio of the Amount(current US$) in Mozambique in 2009 to that in 2010?
Keep it short and to the point. 1.06. What is the ratio of the Amount(current US$) of Kosovo in 2009 to that in 2011?
Make the answer very short. 0.93. What is the ratio of the Amount(current US$) in Mexico in 2009 to that in 2011?
Your response must be concise. 0.67. What is the ratio of the Amount(current US$) in Mozambique in 2009 to that in 2011?
Offer a very short reply. 0.48. What is the ratio of the Amount(current US$) of Kosovo in 2009 to that in 2012?
Your answer should be compact. 1.01. What is the ratio of the Amount(current US$) of Mexico in 2009 to that in 2012?
Give a very brief answer. 0.63. What is the ratio of the Amount(current US$) of Mozambique in 2009 to that in 2012?
Provide a short and direct response. 0.45. What is the ratio of the Amount(current US$) in Kosovo in 2009 to that in 2013?
Ensure brevity in your answer.  0.96. What is the ratio of the Amount(current US$) of Mexico in 2009 to that in 2013?
Give a very brief answer. 0.61. What is the ratio of the Amount(current US$) in Mozambique in 2009 to that in 2013?
Make the answer very short. 0.34. What is the ratio of the Amount(current US$) in Kosovo in 2010 to that in 2011?
Provide a short and direct response. 0.9. What is the ratio of the Amount(current US$) of Mexico in 2010 to that in 2011?
Your answer should be compact. 0.86. What is the ratio of the Amount(current US$) of Mozambique in 2010 to that in 2011?
Your answer should be compact. 0.46. What is the ratio of the Amount(current US$) of Kosovo in 2010 to that in 2012?
Your answer should be compact. 0.98. What is the ratio of the Amount(current US$) in Mexico in 2010 to that in 2012?
Provide a succinct answer. 0.81. What is the ratio of the Amount(current US$) of Mozambique in 2010 to that in 2012?
Give a very brief answer. 0.42. What is the ratio of the Amount(current US$) of Kosovo in 2010 to that in 2013?
Your answer should be compact. 0.93. What is the ratio of the Amount(current US$) of Mexico in 2010 to that in 2013?
Your answer should be compact. 0.79. What is the ratio of the Amount(current US$) in Mozambique in 2010 to that in 2013?
Make the answer very short. 0.32. What is the ratio of the Amount(current US$) of Kosovo in 2011 to that in 2012?
Ensure brevity in your answer.  1.09. What is the ratio of the Amount(current US$) in Mexico in 2011 to that in 2012?
Give a very brief answer. 0.95. What is the ratio of the Amount(current US$) of Mozambique in 2011 to that in 2012?
Your answer should be very brief. 0.92. What is the ratio of the Amount(current US$) of Kosovo in 2011 to that in 2013?
Offer a terse response. 1.04. What is the ratio of the Amount(current US$) in Mexico in 2011 to that in 2013?
Offer a very short reply. 0.92. What is the ratio of the Amount(current US$) of Mozambique in 2011 to that in 2013?
Your response must be concise. 0.7. What is the ratio of the Amount(current US$) of Kosovo in 2012 to that in 2013?
Your answer should be compact. 0.95. What is the ratio of the Amount(current US$) of Mexico in 2012 to that in 2013?
Ensure brevity in your answer.  0.97. What is the ratio of the Amount(current US$) in Mozambique in 2012 to that in 2013?
Provide a succinct answer. 0.76. What is the difference between the highest and the second highest Amount(current US$) of Kosovo?
Provide a short and direct response. 5.49e+07. What is the difference between the highest and the second highest Amount(current US$) of Mexico?
Give a very brief answer. 1.15e+1. What is the difference between the highest and the second highest Amount(current US$) in Mozambique?
Ensure brevity in your answer.  2.70e+09. What is the difference between the highest and the lowest Amount(current US$) of Kosovo?
Keep it short and to the point. 1.09e+09. What is the difference between the highest and the lowest Amount(current US$) in Mexico?
Your answer should be very brief. 1.62e+11. What is the difference between the highest and the lowest Amount(current US$) in Mozambique?
Your answer should be compact. 8.22e+09. 